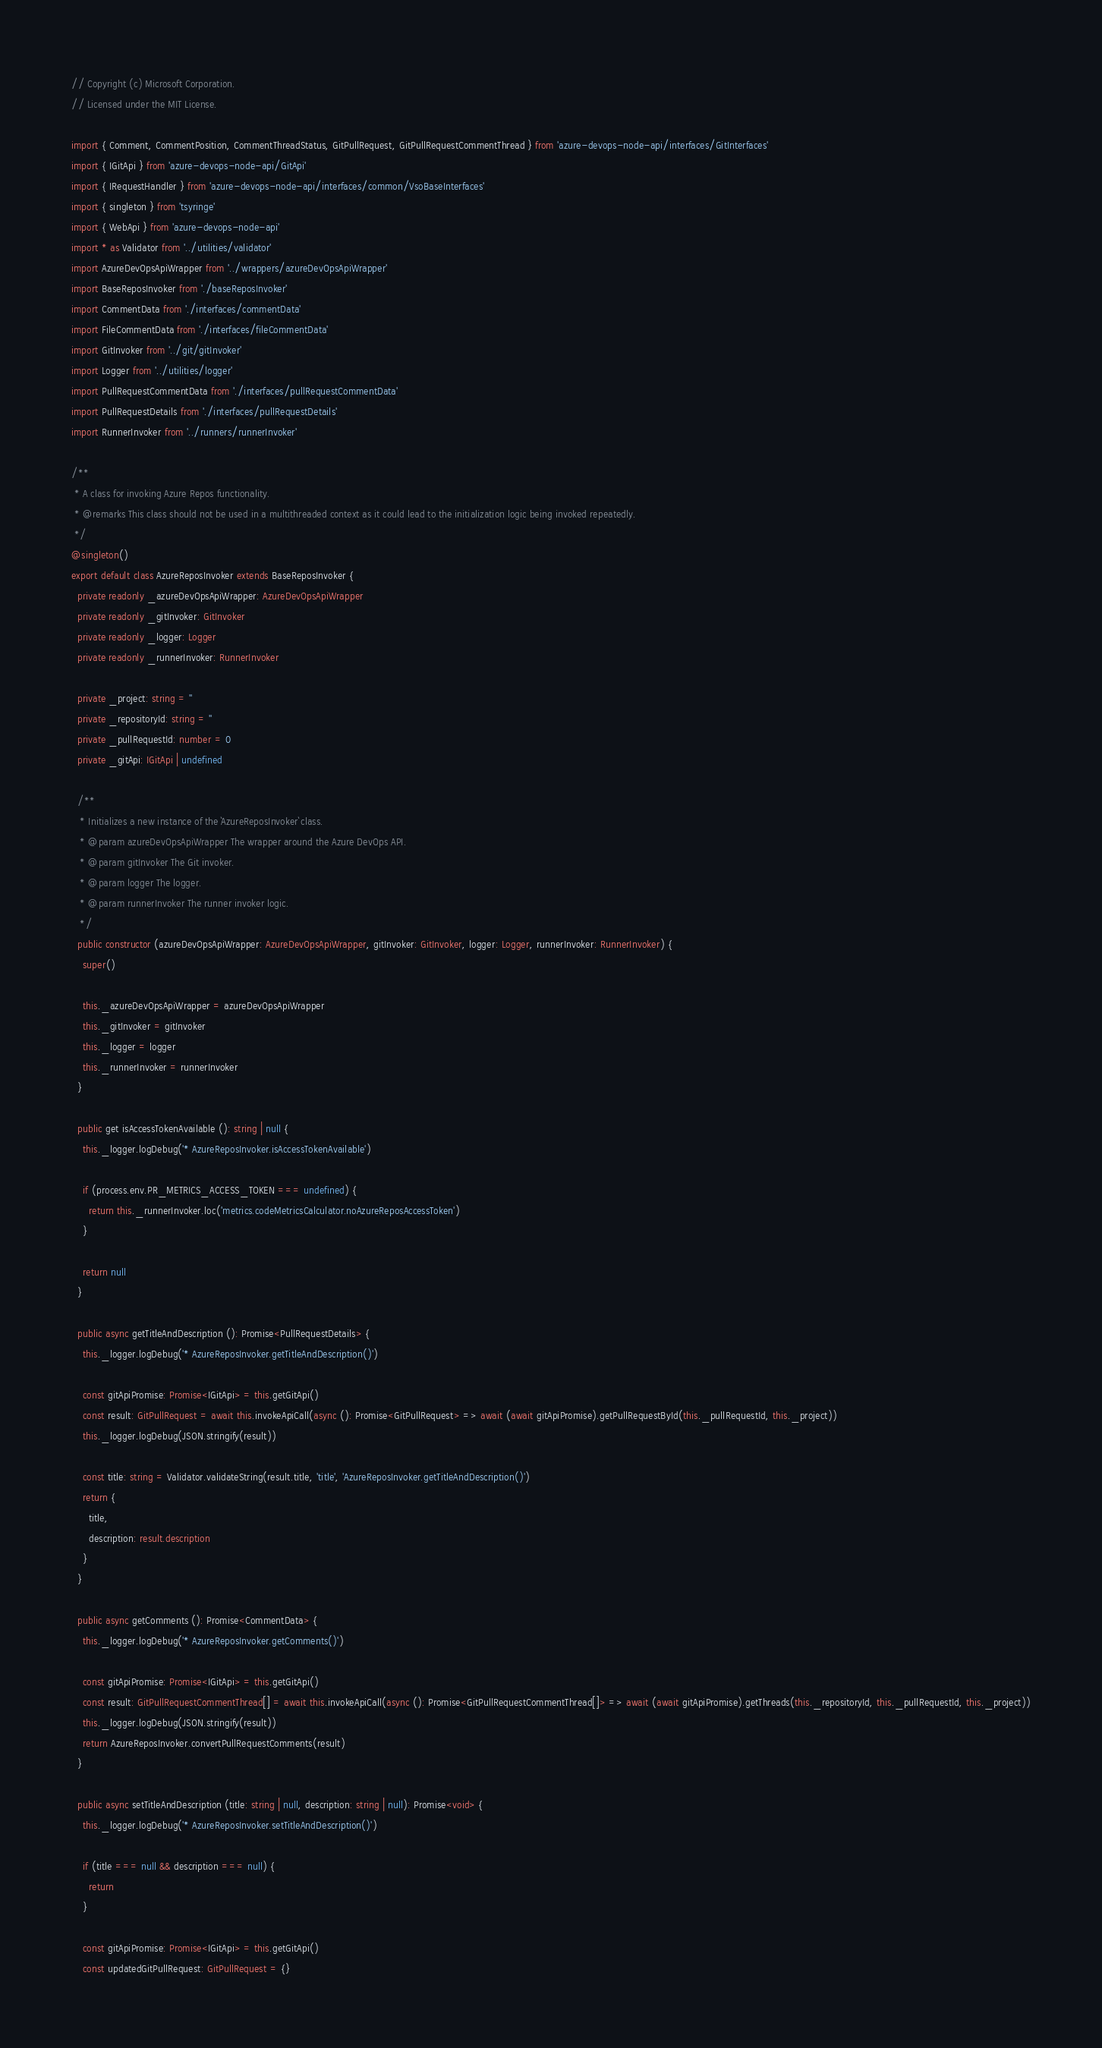<code> <loc_0><loc_0><loc_500><loc_500><_TypeScript_>// Copyright (c) Microsoft Corporation.
// Licensed under the MIT License.

import { Comment, CommentPosition, CommentThreadStatus, GitPullRequest, GitPullRequestCommentThread } from 'azure-devops-node-api/interfaces/GitInterfaces'
import { IGitApi } from 'azure-devops-node-api/GitApi'
import { IRequestHandler } from 'azure-devops-node-api/interfaces/common/VsoBaseInterfaces'
import { singleton } from 'tsyringe'
import { WebApi } from 'azure-devops-node-api'
import * as Validator from '../utilities/validator'
import AzureDevOpsApiWrapper from '../wrappers/azureDevOpsApiWrapper'
import BaseReposInvoker from './baseReposInvoker'
import CommentData from './interfaces/commentData'
import FileCommentData from './interfaces/fileCommentData'
import GitInvoker from '../git/gitInvoker'
import Logger from '../utilities/logger'
import PullRequestCommentData from './interfaces/pullRequestCommentData'
import PullRequestDetails from './interfaces/pullRequestDetails'
import RunnerInvoker from '../runners/runnerInvoker'

/**
 * A class for invoking Azure Repos functionality.
 * @remarks This class should not be used in a multithreaded context as it could lead to the initialization logic being invoked repeatedly.
 */
@singleton()
export default class AzureReposInvoker extends BaseReposInvoker {
  private readonly _azureDevOpsApiWrapper: AzureDevOpsApiWrapper
  private readonly _gitInvoker: GitInvoker
  private readonly _logger: Logger
  private readonly _runnerInvoker: RunnerInvoker

  private _project: string = ''
  private _repositoryId: string = ''
  private _pullRequestId: number = 0
  private _gitApi: IGitApi | undefined

  /**
   * Initializes a new instance of the `AzureReposInvoker` class.
   * @param azureDevOpsApiWrapper The wrapper around the Azure DevOps API.
   * @param gitInvoker The Git invoker.
   * @param logger The logger.
   * @param runnerInvoker The runner invoker logic.
   */
  public constructor (azureDevOpsApiWrapper: AzureDevOpsApiWrapper, gitInvoker: GitInvoker, logger: Logger, runnerInvoker: RunnerInvoker) {
    super()

    this._azureDevOpsApiWrapper = azureDevOpsApiWrapper
    this._gitInvoker = gitInvoker
    this._logger = logger
    this._runnerInvoker = runnerInvoker
  }

  public get isAccessTokenAvailable (): string | null {
    this._logger.logDebug('* AzureReposInvoker.isAccessTokenAvailable')

    if (process.env.PR_METRICS_ACCESS_TOKEN === undefined) {
      return this._runnerInvoker.loc('metrics.codeMetricsCalculator.noAzureReposAccessToken')
    }

    return null
  }

  public async getTitleAndDescription (): Promise<PullRequestDetails> {
    this._logger.logDebug('* AzureReposInvoker.getTitleAndDescription()')

    const gitApiPromise: Promise<IGitApi> = this.getGitApi()
    const result: GitPullRequest = await this.invokeApiCall(async (): Promise<GitPullRequest> => await (await gitApiPromise).getPullRequestById(this._pullRequestId, this._project))
    this._logger.logDebug(JSON.stringify(result))

    const title: string = Validator.validateString(result.title, 'title', 'AzureReposInvoker.getTitleAndDescription()')
    return {
      title,
      description: result.description
    }
  }

  public async getComments (): Promise<CommentData> {
    this._logger.logDebug('* AzureReposInvoker.getComments()')

    const gitApiPromise: Promise<IGitApi> = this.getGitApi()
    const result: GitPullRequestCommentThread[] = await this.invokeApiCall(async (): Promise<GitPullRequestCommentThread[]> => await (await gitApiPromise).getThreads(this._repositoryId, this._pullRequestId, this._project))
    this._logger.logDebug(JSON.stringify(result))
    return AzureReposInvoker.convertPullRequestComments(result)
  }

  public async setTitleAndDescription (title: string | null, description: string | null): Promise<void> {
    this._logger.logDebug('* AzureReposInvoker.setTitleAndDescription()')

    if (title === null && description === null) {
      return
    }

    const gitApiPromise: Promise<IGitApi> = this.getGitApi()
    const updatedGitPullRequest: GitPullRequest = {}</code> 